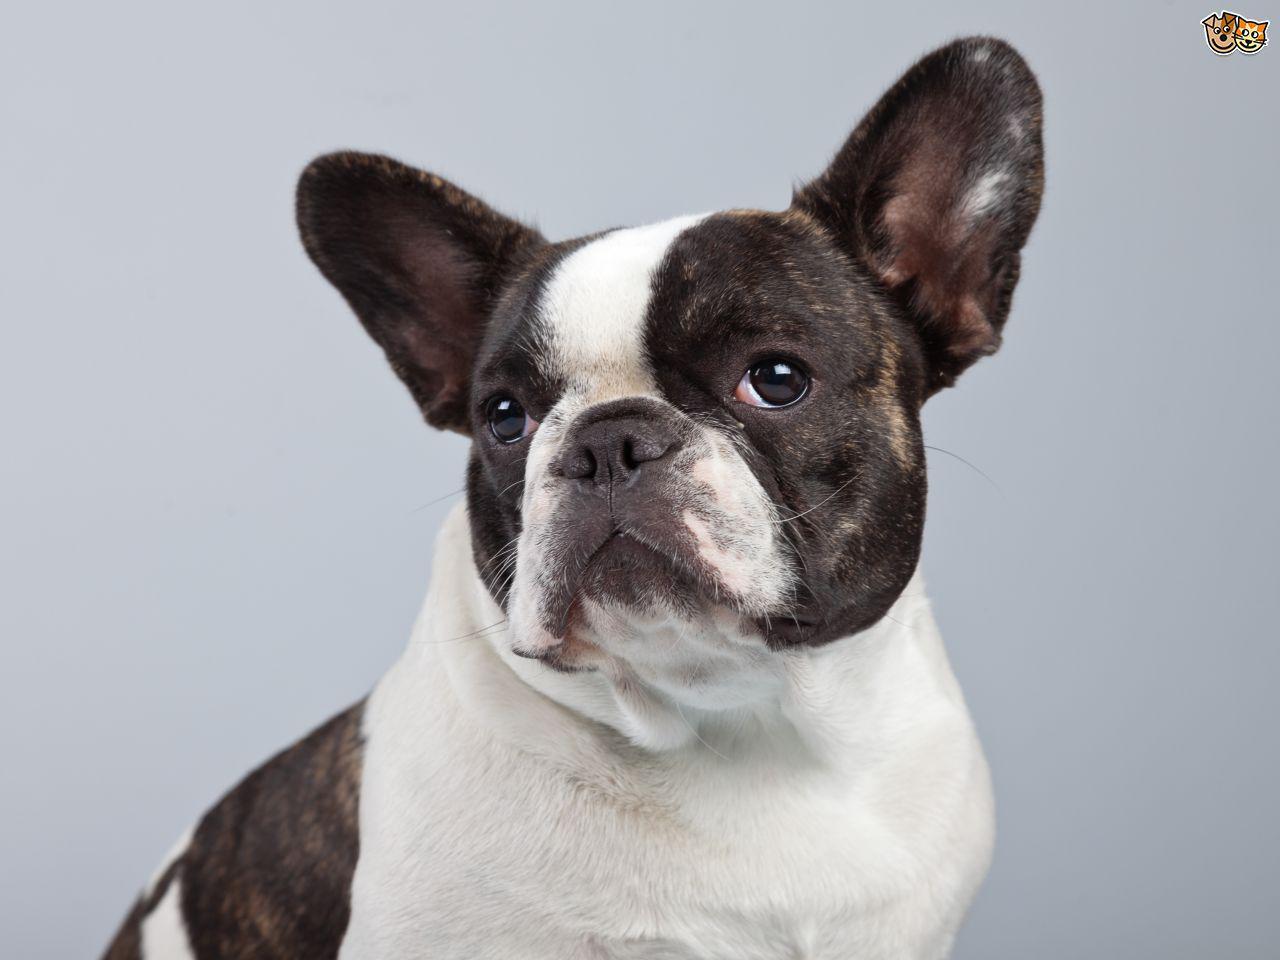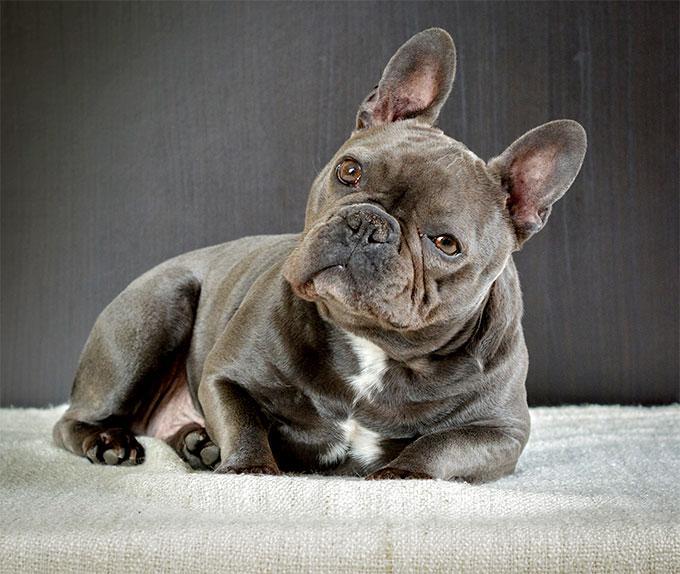The first image is the image on the left, the second image is the image on the right. Analyze the images presented: Is the assertion "There are two dogs shown in total." valid? Answer yes or no. Yes. The first image is the image on the left, the second image is the image on the right. Considering the images on both sides, is "There are two dogs" valid? Answer yes or no. Yes. 